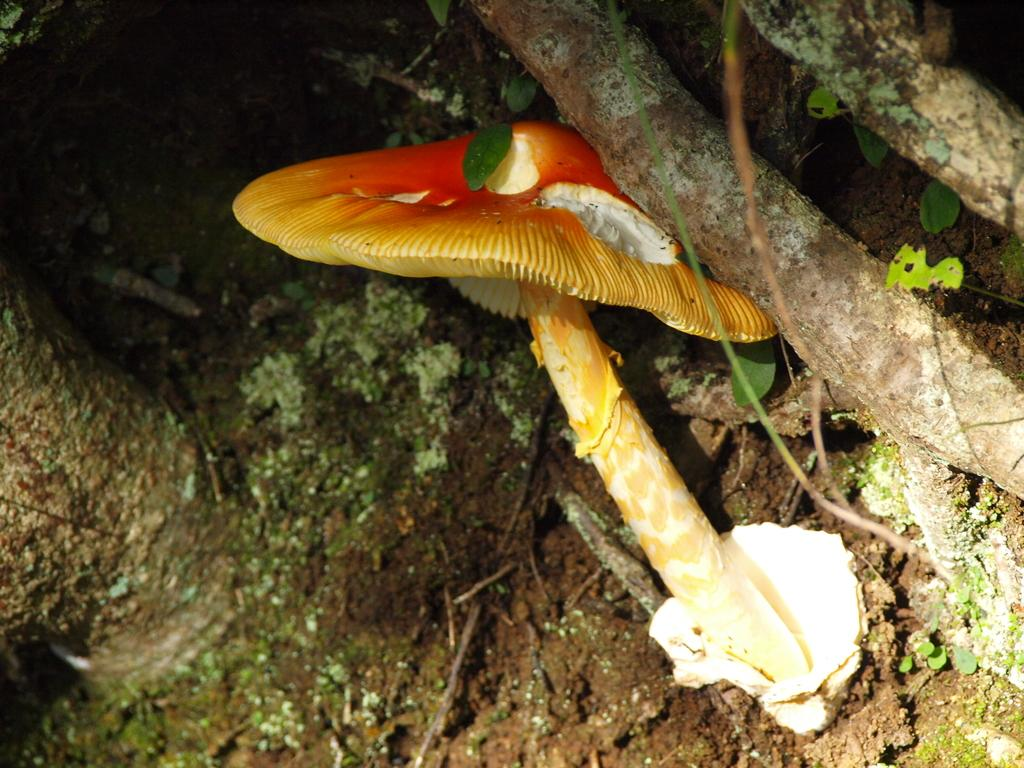What colors are the mushrooms in the image? The mushrooms in the image are yellow and orange. What can be seen growing on the ground in the image? There are mushrooms growing on the ground in the image. What else is visible in the image besides the mushrooms? Plant roots are visible in the image. Can you see a kitty playing with a banana near the mushrooms in the image? No, there is no kitty or banana present in the image. 